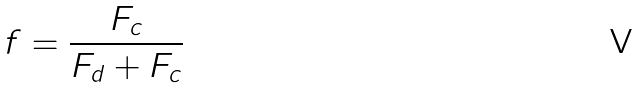Convert formula to latex. <formula><loc_0><loc_0><loc_500><loc_500>f = \frac { F _ { c } } { F _ { d } + F _ { c } }</formula> 